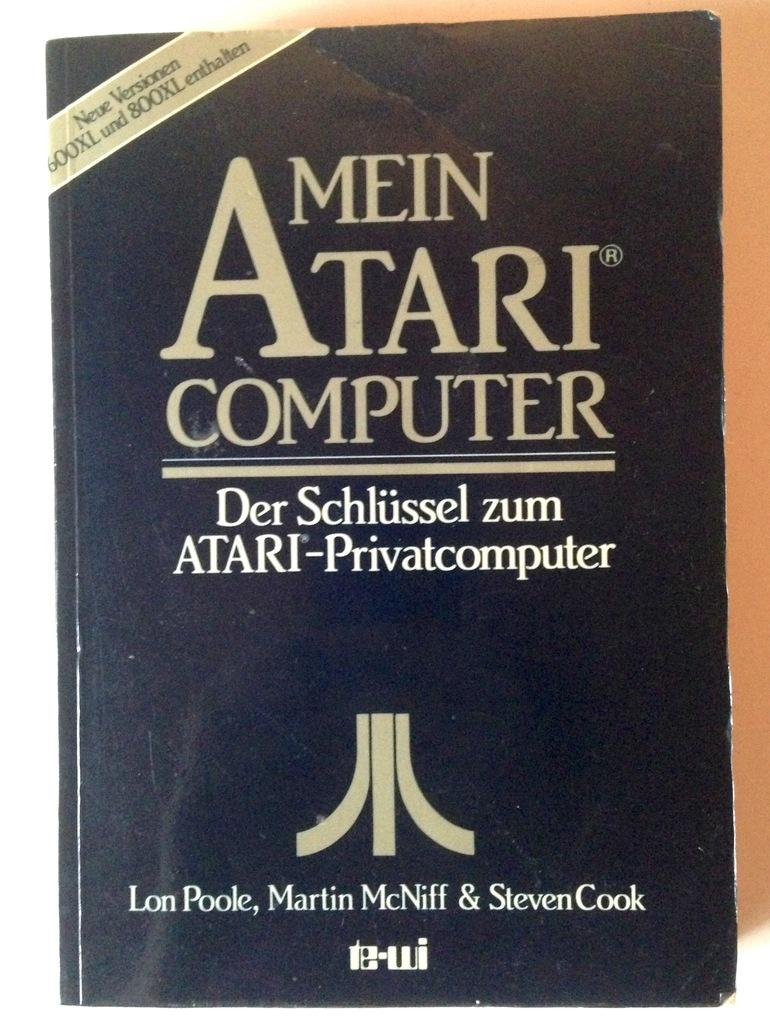<image>
Present a compact description of the photo's key features. The cover of the book titled Mein Atari computer with the atari logo on the bottom. 